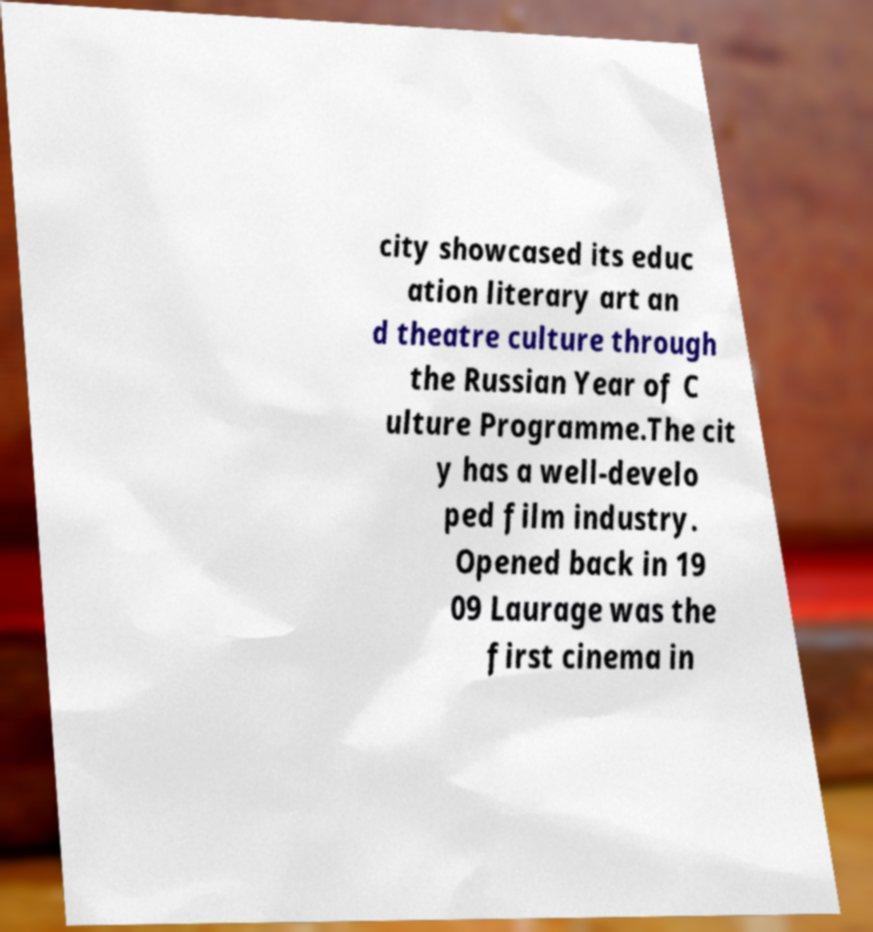Could you assist in decoding the text presented in this image and type it out clearly? city showcased its educ ation literary art an d theatre culture through the Russian Year of C ulture Programme.The cit y has a well-develo ped film industry. Opened back in 19 09 Laurage was the first cinema in 